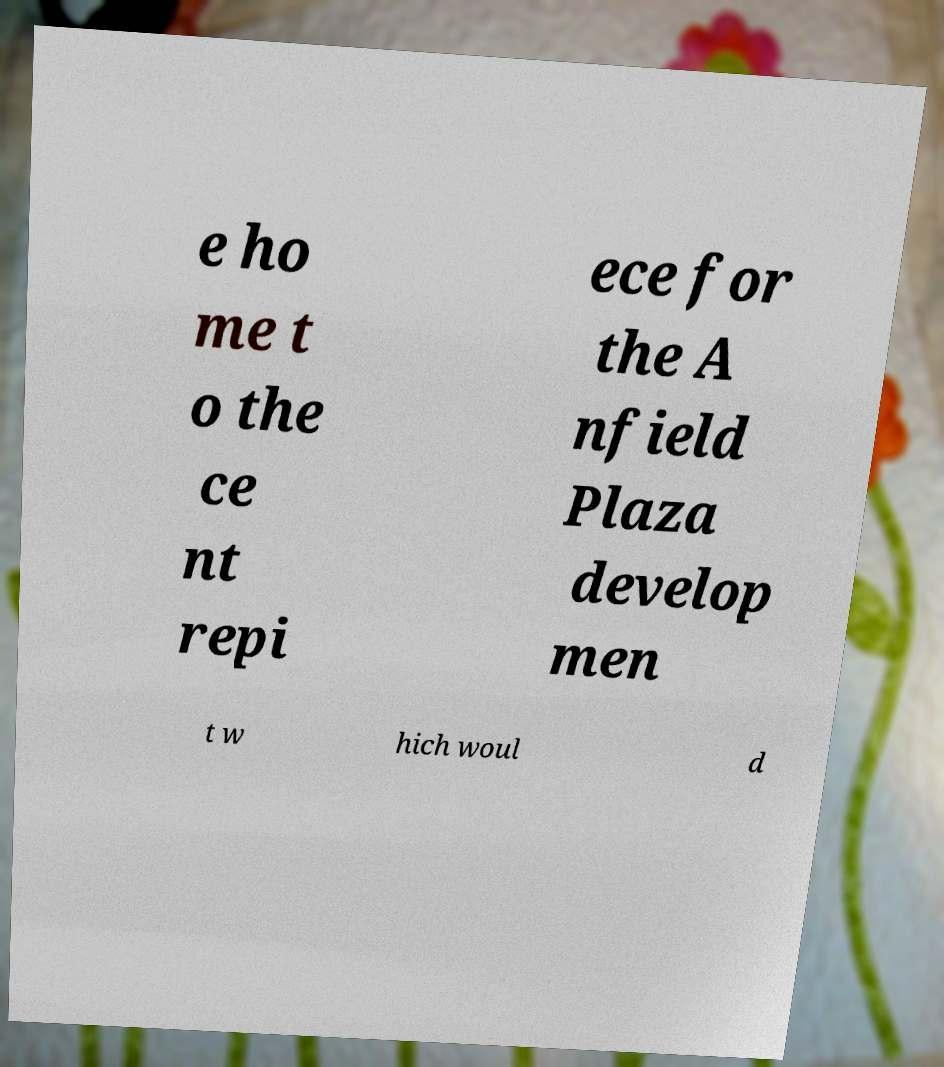Please identify and transcribe the text found in this image. e ho me t o the ce nt repi ece for the A nfield Plaza develop men t w hich woul d 